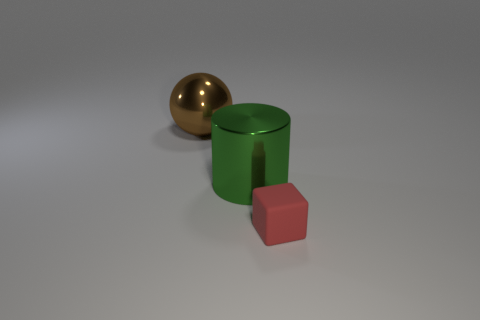Is there anything else that has the same material as the tiny thing?
Give a very brief answer. No. What number of matte objects are either large brown objects or large green spheres?
Give a very brief answer. 0. Are there any other brown matte cubes of the same size as the matte block?
Make the answer very short. No. What number of brown shiny spheres are the same size as the metallic cylinder?
Your response must be concise. 1. There is a shiny object on the right side of the brown ball; is it the same size as the thing that is right of the green metallic object?
Ensure brevity in your answer.  No. What number of objects are red cubes or tiny red cubes in front of the brown sphere?
Ensure brevity in your answer.  1. The tiny cube is what color?
Provide a short and direct response. Red. What material is the object behind the big metal object on the right side of the object that is on the left side of the green metal cylinder?
Your answer should be very brief. Metal. Do the rubber object and the metal object on the right side of the big metallic ball have the same size?
Keep it short and to the point. No. What number of things are to the left of the object that is in front of the green metal cylinder that is in front of the large ball?
Provide a short and direct response. 2. 